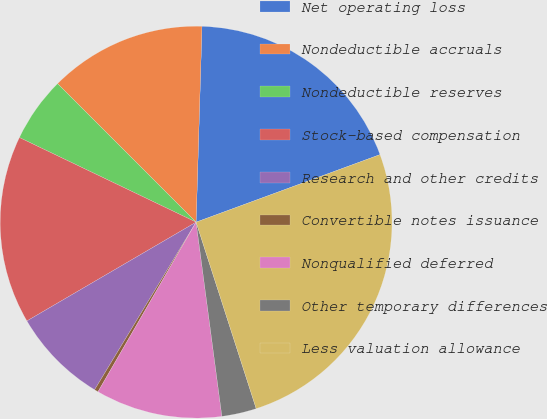Convert chart to OTSL. <chart><loc_0><loc_0><loc_500><loc_500><pie_chart><fcel>Net operating loss<fcel>Nondeductible accruals<fcel>Nondeductible reserves<fcel>Stock-based compensation<fcel>Research and other credits<fcel>Convertible notes issuance<fcel>Nonqualified deferred<fcel>Other temporary differences<fcel>Less valuation allowance<nl><fcel>18.92%<fcel>12.98%<fcel>5.39%<fcel>15.52%<fcel>7.92%<fcel>0.32%<fcel>10.45%<fcel>2.86%<fcel>25.64%<nl></chart> 